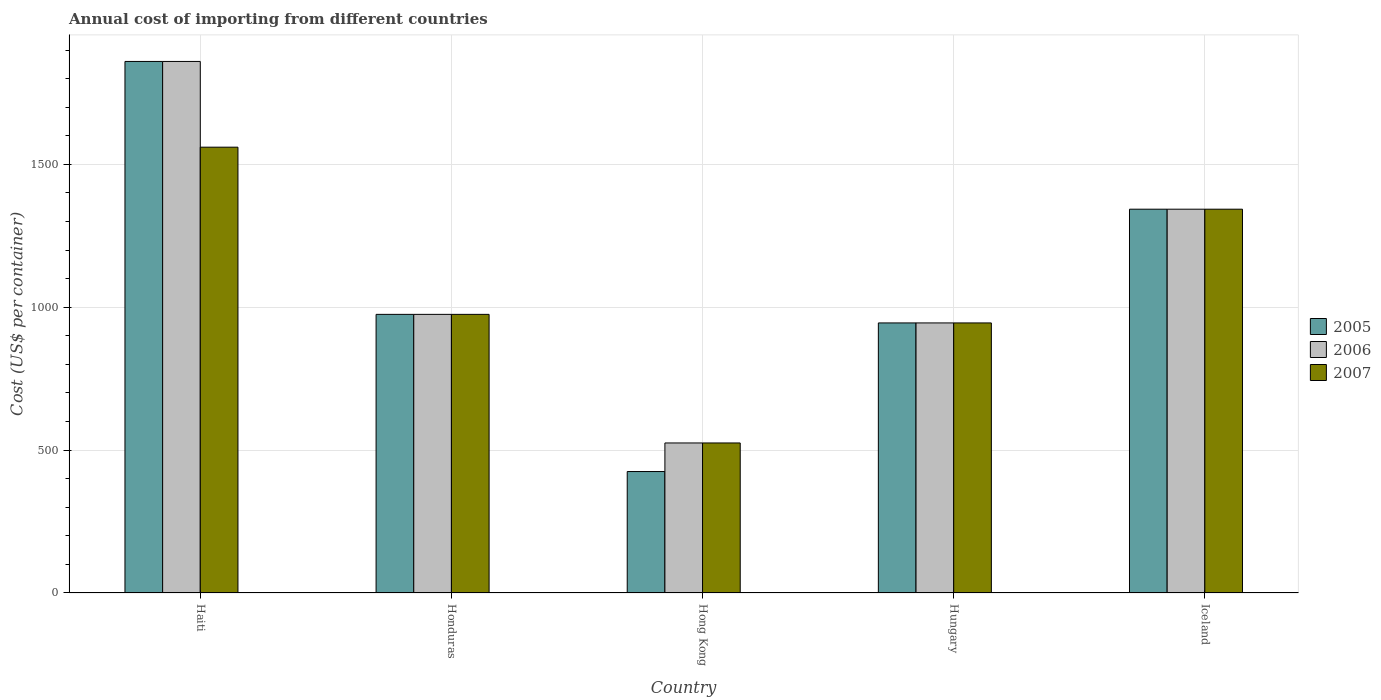How many groups of bars are there?
Make the answer very short. 5. Are the number of bars on each tick of the X-axis equal?
Provide a short and direct response. Yes. What is the label of the 2nd group of bars from the left?
Offer a very short reply. Honduras. What is the total annual cost of importing in 2007 in Hong Kong?
Your response must be concise. 525. Across all countries, what is the maximum total annual cost of importing in 2007?
Make the answer very short. 1560. Across all countries, what is the minimum total annual cost of importing in 2006?
Offer a terse response. 525. In which country was the total annual cost of importing in 2006 maximum?
Your response must be concise. Haiti. In which country was the total annual cost of importing in 2007 minimum?
Give a very brief answer. Hong Kong. What is the total total annual cost of importing in 2006 in the graph?
Provide a succinct answer. 5648. What is the difference between the total annual cost of importing in 2005 in Iceland and the total annual cost of importing in 2007 in Hong Kong?
Provide a short and direct response. 818. What is the average total annual cost of importing in 2006 per country?
Make the answer very short. 1129.6. What is the difference between the total annual cost of importing of/in 2007 and total annual cost of importing of/in 2006 in Hong Kong?
Provide a short and direct response. 0. In how many countries, is the total annual cost of importing in 2006 greater than 1100 US$?
Ensure brevity in your answer.  2. What is the ratio of the total annual cost of importing in 2007 in Honduras to that in Iceland?
Offer a very short reply. 0.73. What is the difference between the highest and the second highest total annual cost of importing in 2006?
Your answer should be very brief. -885. What is the difference between the highest and the lowest total annual cost of importing in 2007?
Provide a succinct answer. 1035. In how many countries, is the total annual cost of importing in 2005 greater than the average total annual cost of importing in 2005 taken over all countries?
Provide a succinct answer. 2. What does the 2nd bar from the left in Hungary represents?
Ensure brevity in your answer.  2006. What does the 2nd bar from the right in Hungary represents?
Provide a short and direct response. 2006. How many bars are there?
Your answer should be very brief. 15. Are all the bars in the graph horizontal?
Provide a succinct answer. No. How many countries are there in the graph?
Ensure brevity in your answer.  5. Does the graph contain any zero values?
Provide a short and direct response. No. Does the graph contain grids?
Offer a terse response. Yes. Where does the legend appear in the graph?
Keep it short and to the point. Center right. How are the legend labels stacked?
Your answer should be compact. Vertical. What is the title of the graph?
Offer a terse response. Annual cost of importing from different countries. Does "2008" appear as one of the legend labels in the graph?
Provide a short and direct response. No. What is the label or title of the Y-axis?
Provide a short and direct response. Cost (US$ per container). What is the Cost (US$ per container) of 2005 in Haiti?
Offer a terse response. 1860. What is the Cost (US$ per container) of 2006 in Haiti?
Provide a short and direct response. 1860. What is the Cost (US$ per container) in 2007 in Haiti?
Your response must be concise. 1560. What is the Cost (US$ per container) in 2005 in Honduras?
Offer a terse response. 975. What is the Cost (US$ per container) in 2006 in Honduras?
Ensure brevity in your answer.  975. What is the Cost (US$ per container) in 2007 in Honduras?
Keep it short and to the point. 975. What is the Cost (US$ per container) of 2005 in Hong Kong?
Offer a terse response. 425. What is the Cost (US$ per container) of 2006 in Hong Kong?
Offer a very short reply. 525. What is the Cost (US$ per container) in 2007 in Hong Kong?
Provide a short and direct response. 525. What is the Cost (US$ per container) of 2005 in Hungary?
Keep it short and to the point. 945. What is the Cost (US$ per container) in 2006 in Hungary?
Provide a short and direct response. 945. What is the Cost (US$ per container) of 2007 in Hungary?
Your answer should be compact. 945. What is the Cost (US$ per container) in 2005 in Iceland?
Offer a terse response. 1343. What is the Cost (US$ per container) of 2006 in Iceland?
Keep it short and to the point. 1343. What is the Cost (US$ per container) of 2007 in Iceland?
Provide a short and direct response. 1343. Across all countries, what is the maximum Cost (US$ per container) of 2005?
Provide a short and direct response. 1860. Across all countries, what is the maximum Cost (US$ per container) in 2006?
Your response must be concise. 1860. Across all countries, what is the maximum Cost (US$ per container) in 2007?
Your answer should be compact. 1560. Across all countries, what is the minimum Cost (US$ per container) of 2005?
Ensure brevity in your answer.  425. Across all countries, what is the minimum Cost (US$ per container) in 2006?
Provide a succinct answer. 525. Across all countries, what is the minimum Cost (US$ per container) in 2007?
Your answer should be compact. 525. What is the total Cost (US$ per container) of 2005 in the graph?
Give a very brief answer. 5548. What is the total Cost (US$ per container) in 2006 in the graph?
Your answer should be very brief. 5648. What is the total Cost (US$ per container) of 2007 in the graph?
Your answer should be compact. 5348. What is the difference between the Cost (US$ per container) of 2005 in Haiti and that in Honduras?
Provide a short and direct response. 885. What is the difference between the Cost (US$ per container) in 2006 in Haiti and that in Honduras?
Provide a short and direct response. 885. What is the difference between the Cost (US$ per container) of 2007 in Haiti and that in Honduras?
Your response must be concise. 585. What is the difference between the Cost (US$ per container) in 2005 in Haiti and that in Hong Kong?
Your answer should be compact. 1435. What is the difference between the Cost (US$ per container) of 2006 in Haiti and that in Hong Kong?
Make the answer very short. 1335. What is the difference between the Cost (US$ per container) of 2007 in Haiti and that in Hong Kong?
Ensure brevity in your answer.  1035. What is the difference between the Cost (US$ per container) in 2005 in Haiti and that in Hungary?
Your answer should be very brief. 915. What is the difference between the Cost (US$ per container) in 2006 in Haiti and that in Hungary?
Your answer should be very brief. 915. What is the difference between the Cost (US$ per container) of 2007 in Haiti and that in Hungary?
Provide a short and direct response. 615. What is the difference between the Cost (US$ per container) of 2005 in Haiti and that in Iceland?
Give a very brief answer. 517. What is the difference between the Cost (US$ per container) of 2006 in Haiti and that in Iceland?
Make the answer very short. 517. What is the difference between the Cost (US$ per container) of 2007 in Haiti and that in Iceland?
Offer a very short reply. 217. What is the difference between the Cost (US$ per container) of 2005 in Honduras and that in Hong Kong?
Make the answer very short. 550. What is the difference between the Cost (US$ per container) of 2006 in Honduras and that in Hong Kong?
Provide a succinct answer. 450. What is the difference between the Cost (US$ per container) of 2007 in Honduras and that in Hong Kong?
Provide a succinct answer. 450. What is the difference between the Cost (US$ per container) in 2005 in Honduras and that in Hungary?
Ensure brevity in your answer.  30. What is the difference between the Cost (US$ per container) in 2005 in Honduras and that in Iceland?
Keep it short and to the point. -368. What is the difference between the Cost (US$ per container) in 2006 in Honduras and that in Iceland?
Keep it short and to the point. -368. What is the difference between the Cost (US$ per container) in 2007 in Honduras and that in Iceland?
Provide a short and direct response. -368. What is the difference between the Cost (US$ per container) of 2005 in Hong Kong and that in Hungary?
Ensure brevity in your answer.  -520. What is the difference between the Cost (US$ per container) in 2006 in Hong Kong and that in Hungary?
Your answer should be compact. -420. What is the difference between the Cost (US$ per container) of 2007 in Hong Kong and that in Hungary?
Give a very brief answer. -420. What is the difference between the Cost (US$ per container) in 2005 in Hong Kong and that in Iceland?
Keep it short and to the point. -918. What is the difference between the Cost (US$ per container) of 2006 in Hong Kong and that in Iceland?
Provide a short and direct response. -818. What is the difference between the Cost (US$ per container) of 2007 in Hong Kong and that in Iceland?
Ensure brevity in your answer.  -818. What is the difference between the Cost (US$ per container) in 2005 in Hungary and that in Iceland?
Offer a very short reply. -398. What is the difference between the Cost (US$ per container) in 2006 in Hungary and that in Iceland?
Keep it short and to the point. -398. What is the difference between the Cost (US$ per container) in 2007 in Hungary and that in Iceland?
Provide a short and direct response. -398. What is the difference between the Cost (US$ per container) of 2005 in Haiti and the Cost (US$ per container) of 2006 in Honduras?
Ensure brevity in your answer.  885. What is the difference between the Cost (US$ per container) of 2005 in Haiti and the Cost (US$ per container) of 2007 in Honduras?
Keep it short and to the point. 885. What is the difference between the Cost (US$ per container) of 2006 in Haiti and the Cost (US$ per container) of 2007 in Honduras?
Your answer should be compact. 885. What is the difference between the Cost (US$ per container) of 2005 in Haiti and the Cost (US$ per container) of 2006 in Hong Kong?
Make the answer very short. 1335. What is the difference between the Cost (US$ per container) in 2005 in Haiti and the Cost (US$ per container) in 2007 in Hong Kong?
Provide a short and direct response. 1335. What is the difference between the Cost (US$ per container) in 2006 in Haiti and the Cost (US$ per container) in 2007 in Hong Kong?
Provide a succinct answer. 1335. What is the difference between the Cost (US$ per container) of 2005 in Haiti and the Cost (US$ per container) of 2006 in Hungary?
Offer a very short reply. 915. What is the difference between the Cost (US$ per container) in 2005 in Haiti and the Cost (US$ per container) in 2007 in Hungary?
Your answer should be compact. 915. What is the difference between the Cost (US$ per container) of 2006 in Haiti and the Cost (US$ per container) of 2007 in Hungary?
Your response must be concise. 915. What is the difference between the Cost (US$ per container) in 2005 in Haiti and the Cost (US$ per container) in 2006 in Iceland?
Your response must be concise. 517. What is the difference between the Cost (US$ per container) in 2005 in Haiti and the Cost (US$ per container) in 2007 in Iceland?
Your answer should be compact. 517. What is the difference between the Cost (US$ per container) in 2006 in Haiti and the Cost (US$ per container) in 2007 in Iceland?
Give a very brief answer. 517. What is the difference between the Cost (US$ per container) in 2005 in Honduras and the Cost (US$ per container) in 2006 in Hong Kong?
Your response must be concise. 450. What is the difference between the Cost (US$ per container) in 2005 in Honduras and the Cost (US$ per container) in 2007 in Hong Kong?
Provide a succinct answer. 450. What is the difference between the Cost (US$ per container) of 2006 in Honduras and the Cost (US$ per container) of 2007 in Hong Kong?
Your response must be concise. 450. What is the difference between the Cost (US$ per container) of 2005 in Honduras and the Cost (US$ per container) of 2006 in Hungary?
Give a very brief answer. 30. What is the difference between the Cost (US$ per container) of 2005 in Honduras and the Cost (US$ per container) of 2007 in Hungary?
Your response must be concise. 30. What is the difference between the Cost (US$ per container) in 2006 in Honduras and the Cost (US$ per container) in 2007 in Hungary?
Ensure brevity in your answer.  30. What is the difference between the Cost (US$ per container) in 2005 in Honduras and the Cost (US$ per container) in 2006 in Iceland?
Your answer should be very brief. -368. What is the difference between the Cost (US$ per container) of 2005 in Honduras and the Cost (US$ per container) of 2007 in Iceland?
Your response must be concise. -368. What is the difference between the Cost (US$ per container) in 2006 in Honduras and the Cost (US$ per container) in 2007 in Iceland?
Your answer should be very brief. -368. What is the difference between the Cost (US$ per container) of 2005 in Hong Kong and the Cost (US$ per container) of 2006 in Hungary?
Keep it short and to the point. -520. What is the difference between the Cost (US$ per container) of 2005 in Hong Kong and the Cost (US$ per container) of 2007 in Hungary?
Offer a terse response. -520. What is the difference between the Cost (US$ per container) of 2006 in Hong Kong and the Cost (US$ per container) of 2007 in Hungary?
Make the answer very short. -420. What is the difference between the Cost (US$ per container) in 2005 in Hong Kong and the Cost (US$ per container) in 2006 in Iceland?
Provide a succinct answer. -918. What is the difference between the Cost (US$ per container) of 2005 in Hong Kong and the Cost (US$ per container) of 2007 in Iceland?
Provide a short and direct response. -918. What is the difference between the Cost (US$ per container) in 2006 in Hong Kong and the Cost (US$ per container) in 2007 in Iceland?
Keep it short and to the point. -818. What is the difference between the Cost (US$ per container) of 2005 in Hungary and the Cost (US$ per container) of 2006 in Iceland?
Ensure brevity in your answer.  -398. What is the difference between the Cost (US$ per container) in 2005 in Hungary and the Cost (US$ per container) in 2007 in Iceland?
Your response must be concise. -398. What is the difference between the Cost (US$ per container) of 2006 in Hungary and the Cost (US$ per container) of 2007 in Iceland?
Make the answer very short. -398. What is the average Cost (US$ per container) of 2005 per country?
Provide a short and direct response. 1109.6. What is the average Cost (US$ per container) in 2006 per country?
Ensure brevity in your answer.  1129.6. What is the average Cost (US$ per container) of 2007 per country?
Ensure brevity in your answer.  1069.6. What is the difference between the Cost (US$ per container) of 2005 and Cost (US$ per container) of 2007 in Haiti?
Make the answer very short. 300. What is the difference between the Cost (US$ per container) of 2006 and Cost (US$ per container) of 2007 in Haiti?
Your answer should be very brief. 300. What is the difference between the Cost (US$ per container) of 2005 and Cost (US$ per container) of 2007 in Honduras?
Offer a terse response. 0. What is the difference between the Cost (US$ per container) in 2006 and Cost (US$ per container) in 2007 in Honduras?
Your response must be concise. 0. What is the difference between the Cost (US$ per container) of 2005 and Cost (US$ per container) of 2006 in Hong Kong?
Your answer should be very brief. -100. What is the difference between the Cost (US$ per container) in 2005 and Cost (US$ per container) in 2007 in Hong Kong?
Provide a short and direct response. -100. What is the difference between the Cost (US$ per container) of 2006 and Cost (US$ per container) of 2007 in Hong Kong?
Your answer should be compact. 0. What is the difference between the Cost (US$ per container) of 2005 and Cost (US$ per container) of 2007 in Hungary?
Your answer should be very brief. 0. What is the difference between the Cost (US$ per container) of 2006 and Cost (US$ per container) of 2007 in Hungary?
Provide a short and direct response. 0. What is the difference between the Cost (US$ per container) in 2005 and Cost (US$ per container) in 2007 in Iceland?
Provide a short and direct response. 0. What is the difference between the Cost (US$ per container) of 2006 and Cost (US$ per container) of 2007 in Iceland?
Ensure brevity in your answer.  0. What is the ratio of the Cost (US$ per container) in 2005 in Haiti to that in Honduras?
Offer a very short reply. 1.91. What is the ratio of the Cost (US$ per container) of 2006 in Haiti to that in Honduras?
Ensure brevity in your answer.  1.91. What is the ratio of the Cost (US$ per container) in 2007 in Haiti to that in Honduras?
Provide a short and direct response. 1.6. What is the ratio of the Cost (US$ per container) of 2005 in Haiti to that in Hong Kong?
Your answer should be very brief. 4.38. What is the ratio of the Cost (US$ per container) of 2006 in Haiti to that in Hong Kong?
Provide a short and direct response. 3.54. What is the ratio of the Cost (US$ per container) of 2007 in Haiti to that in Hong Kong?
Your answer should be compact. 2.97. What is the ratio of the Cost (US$ per container) in 2005 in Haiti to that in Hungary?
Keep it short and to the point. 1.97. What is the ratio of the Cost (US$ per container) in 2006 in Haiti to that in Hungary?
Offer a terse response. 1.97. What is the ratio of the Cost (US$ per container) of 2007 in Haiti to that in Hungary?
Offer a very short reply. 1.65. What is the ratio of the Cost (US$ per container) in 2005 in Haiti to that in Iceland?
Give a very brief answer. 1.39. What is the ratio of the Cost (US$ per container) in 2006 in Haiti to that in Iceland?
Your response must be concise. 1.39. What is the ratio of the Cost (US$ per container) of 2007 in Haiti to that in Iceland?
Your answer should be very brief. 1.16. What is the ratio of the Cost (US$ per container) of 2005 in Honduras to that in Hong Kong?
Offer a very short reply. 2.29. What is the ratio of the Cost (US$ per container) in 2006 in Honduras to that in Hong Kong?
Provide a succinct answer. 1.86. What is the ratio of the Cost (US$ per container) in 2007 in Honduras to that in Hong Kong?
Your response must be concise. 1.86. What is the ratio of the Cost (US$ per container) of 2005 in Honduras to that in Hungary?
Offer a very short reply. 1.03. What is the ratio of the Cost (US$ per container) in 2006 in Honduras to that in Hungary?
Ensure brevity in your answer.  1.03. What is the ratio of the Cost (US$ per container) in 2007 in Honduras to that in Hungary?
Your answer should be compact. 1.03. What is the ratio of the Cost (US$ per container) of 2005 in Honduras to that in Iceland?
Your response must be concise. 0.73. What is the ratio of the Cost (US$ per container) of 2006 in Honduras to that in Iceland?
Make the answer very short. 0.73. What is the ratio of the Cost (US$ per container) in 2007 in Honduras to that in Iceland?
Give a very brief answer. 0.73. What is the ratio of the Cost (US$ per container) of 2005 in Hong Kong to that in Hungary?
Keep it short and to the point. 0.45. What is the ratio of the Cost (US$ per container) of 2006 in Hong Kong to that in Hungary?
Give a very brief answer. 0.56. What is the ratio of the Cost (US$ per container) in 2007 in Hong Kong to that in Hungary?
Your response must be concise. 0.56. What is the ratio of the Cost (US$ per container) of 2005 in Hong Kong to that in Iceland?
Provide a succinct answer. 0.32. What is the ratio of the Cost (US$ per container) in 2006 in Hong Kong to that in Iceland?
Your answer should be compact. 0.39. What is the ratio of the Cost (US$ per container) of 2007 in Hong Kong to that in Iceland?
Provide a succinct answer. 0.39. What is the ratio of the Cost (US$ per container) of 2005 in Hungary to that in Iceland?
Offer a terse response. 0.7. What is the ratio of the Cost (US$ per container) in 2006 in Hungary to that in Iceland?
Make the answer very short. 0.7. What is the ratio of the Cost (US$ per container) in 2007 in Hungary to that in Iceland?
Provide a succinct answer. 0.7. What is the difference between the highest and the second highest Cost (US$ per container) of 2005?
Your answer should be compact. 517. What is the difference between the highest and the second highest Cost (US$ per container) of 2006?
Your answer should be compact. 517. What is the difference between the highest and the second highest Cost (US$ per container) in 2007?
Give a very brief answer. 217. What is the difference between the highest and the lowest Cost (US$ per container) in 2005?
Provide a succinct answer. 1435. What is the difference between the highest and the lowest Cost (US$ per container) in 2006?
Give a very brief answer. 1335. What is the difference between the highest and the lowest Cost (US$ per container) in 2007?
Your response must be concise. 1035. 